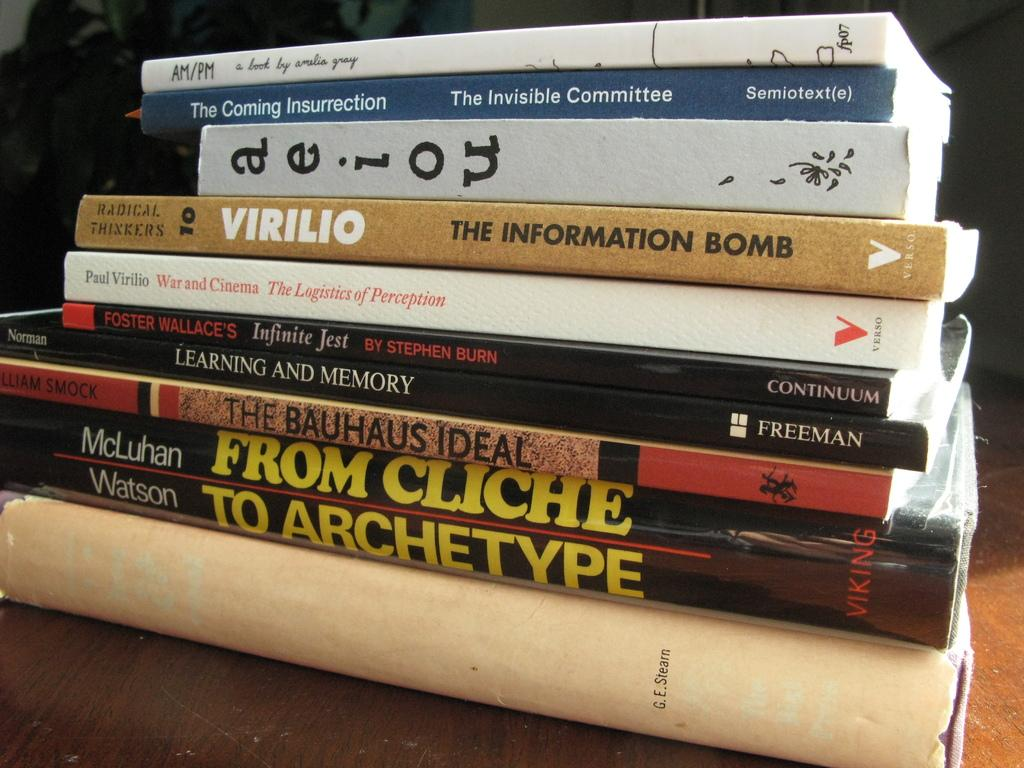<image>
Relay a brief, clear account of the picture shown. The fourth book from the top is titled The Information Bomb. 